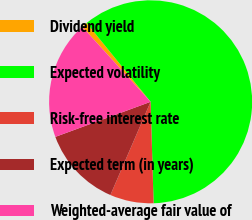Convert chart. <chart><loc_0><loc_0><loc_500><loc_500><pie_chart><fcel>Dividend yield<fcel>Expected volatility<fcel>Risk-free interest rate<fcel>Expected term (in years)<fcel>Weighted-average fair value of<nl><fcel>0.91%<fcel>60.38%<fcel>6.95%<fcel>12.9%<fcel>18.85%<nl></chart> 